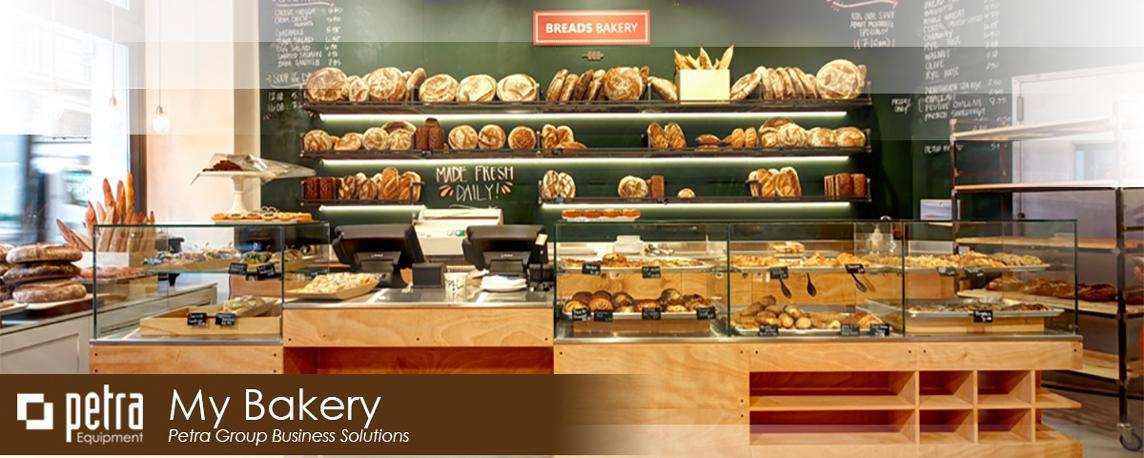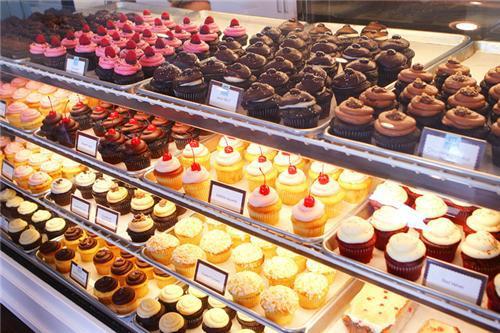The first image is the image on the left, the second image is the image on the right. Examine the images to the left and right. Is the description "There are windows in the image on the right." accurate? Answer yes or no. No. 